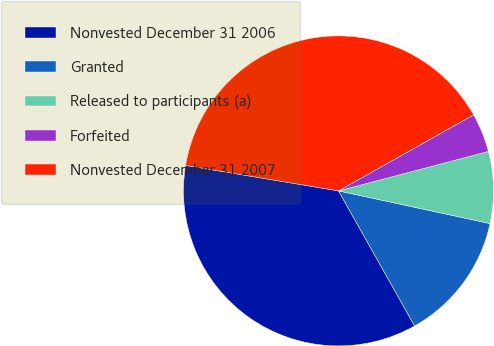Convert chart to OTSL. <chart><loc_0><loc_0><loc_500><loc_500><pie_chart><fcel>Nonvested December 31 2006<fcel>Granted<fcel>Released to participants (a)<fcel>Forfeited<fcel>Nonvested December 31 2007<nl><fcel>35.8%<fcel>13.45%<fcel>7.48%<fcel>4.06%<fcel>39.22%<nl></chart> 